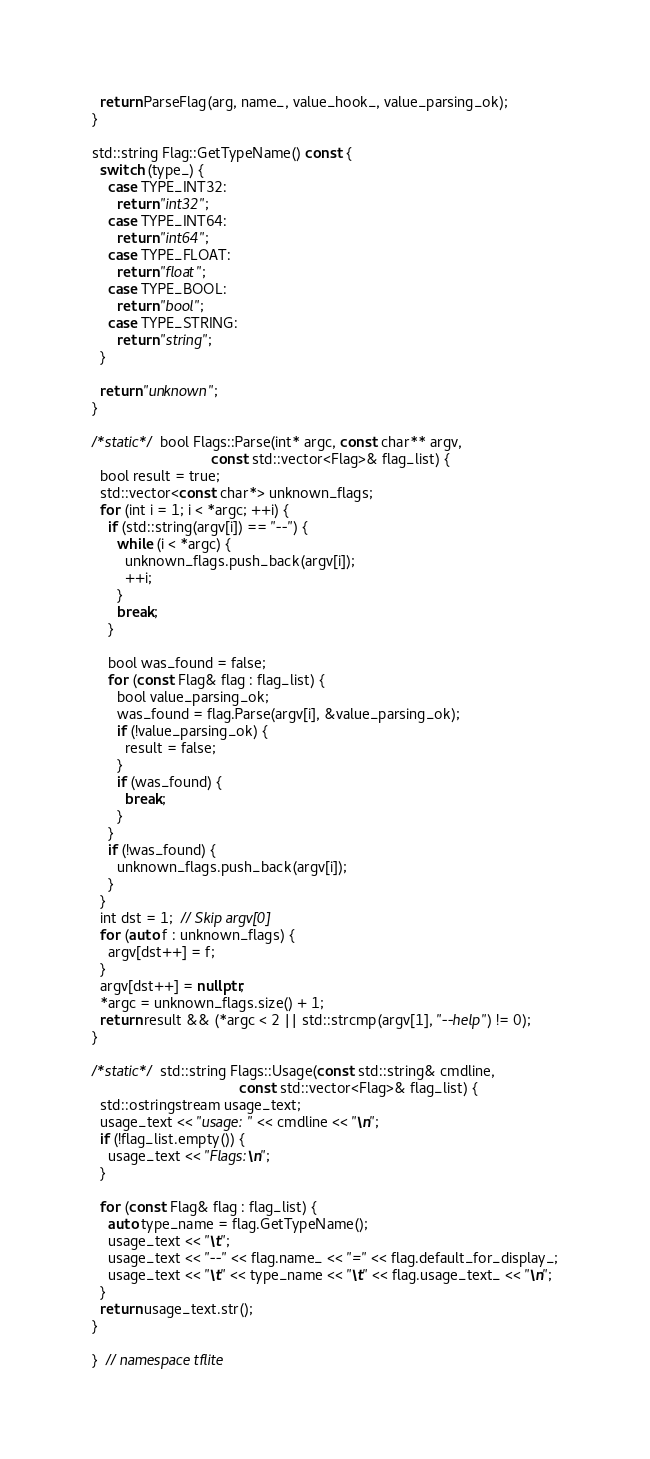Convert code to text. <code><loc_0><loc_0><loc_500><loc_500><_C++_>  return ParseFlag(arg, name_, value_hook_, value_parsing_ok);
}

std::string Flag::GetTypeName() const {
  switch (type_) {
    case TYPE_INT32:
      return "int32";
    case TYPE_INT64:
      return "int64";
    case TYPE_FLOAT:
      return "float";
    case TYPE_BOOL:
      return "bool";
    case TYPE_STRING:
      return "string";
  }

  return "unknown";
}

/*static*/ bool Flags::Parse(int* argc, const char** argv,
                             const std::vector<Flag>& flag_list) {
  bool result = true;
  std::vector<const char*> unknown_flags;
  for (int i = 1; i < *argc; ++i) {
    if (std::string(argv[i]) == "--") {
      while (i < *argc) {
        unknown_flags.push_back(argv[i]);
        ++i;
      }
      break;
    }

    bool was_found = false;
    for (const Flag& flag : flag_list) {
      bool value_parsing_ok;
      was_found = flag.Parse(argv[i], &value_parsing_ok);
      if (!value_parsing_ok) {
        result = false;
      }
      if (was_found) {
        break;
      }
    }
    if (!was_found) {
      unknown_flags.push_back(argv[i]);
    }
  }
  int dst = 1;  // Skip argv[0]
  for (auto f : unknown_flags) {
    argv[dst++] = f;
  }
  argv[dst++] = nullptr;
  *argc = unknown_flags.size() + 1;
  return result && (*argc < 2 || std::strcmp(argv[1], "--help") != 0);
}

/*static*/ std::string Flags::Usage(const std::string& cmdline,
                                    const std::vector<Flag>& flag_list) {
  std::ostringstream usage_text;
  usage_text << "usage: " << cmdline << "\n";
  if (!flag_list.empty()) {
    usage_text << "Flags:\n";
  }

  for (const Flag& flag : flag_list) {
    auto type_name = flag.GetTypeName();
    usage_text << "\t";
    usage_text << "--" << flag.name_ << "=" << flag.default_for_display_;
    usage_text << "\t" << type_name << "\t" << flag.usage_text_ << "\n";
  }
  return usage_text.str();
}

}  // namespace tflite
</code> 